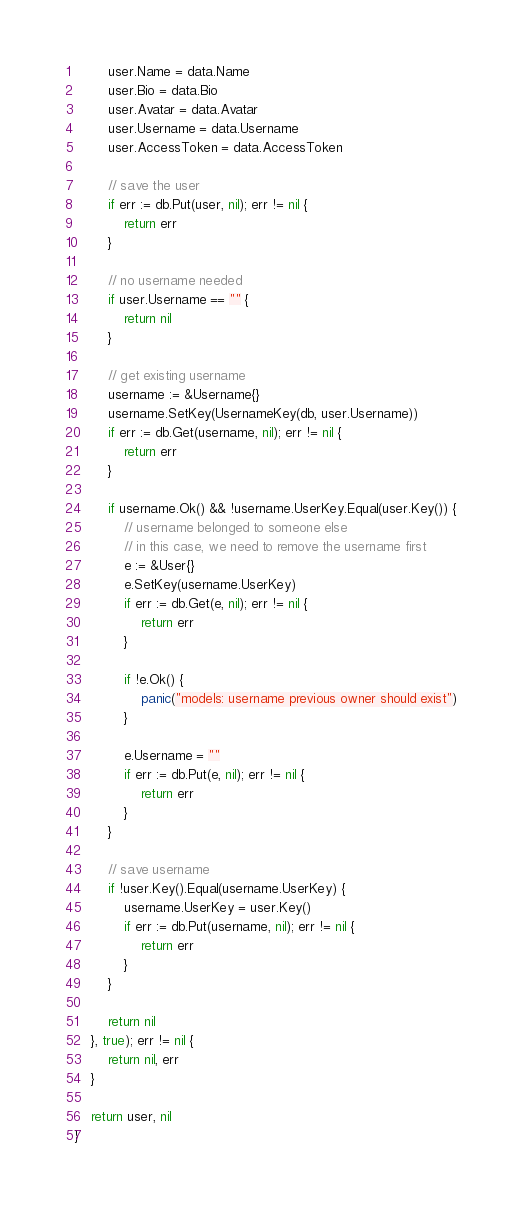Convert code to text. <code><loc_0><loc_0><loc_500><loc_500><_Go_>        user.Name = data.Name
        user.Bio = data.Bio
        user.Avatar = data.Avatar
        user.Username = data.Username
        user.AccessToken = data.AccessToken

        // save the user
        if err := db.Put(user, nil); err != nil {
            return err
        }

        // no username needed
        if user.Username == "" {
            return nil
        }

        // get existing username
        username := &Username{}
        username.SetKey(UsernameKey(db, user.Username))
        if err := db.Get(username, nil); err != nil {
            return err
        }

        if username.Ok() && !username.UserKey.Equal(user.Key()) {
            // username belonged to someone else
            // in this case, we need to remove the username first
            e := &User{}
            e.SetKey(username.UserKey)
            if err := db.Get(e, nil); err != nil {
                return err
            }

            if !e.Ok() {
                panic("models: username previous owner should exist")
            }

            e.Username = ""
            if err := db.Put(e, nil); err != nil {
                return err
            }
        }

        // save username
        if !user.Key().Equal(username.UserKey) {
            username.UserKey = user.Key()
            if err := db.Put(username, nil); err != nil {
                return err
            }
        }

        return nil
    }, true); err != nil {
        return nil, err
    }

    return user, nil
}
</code> 